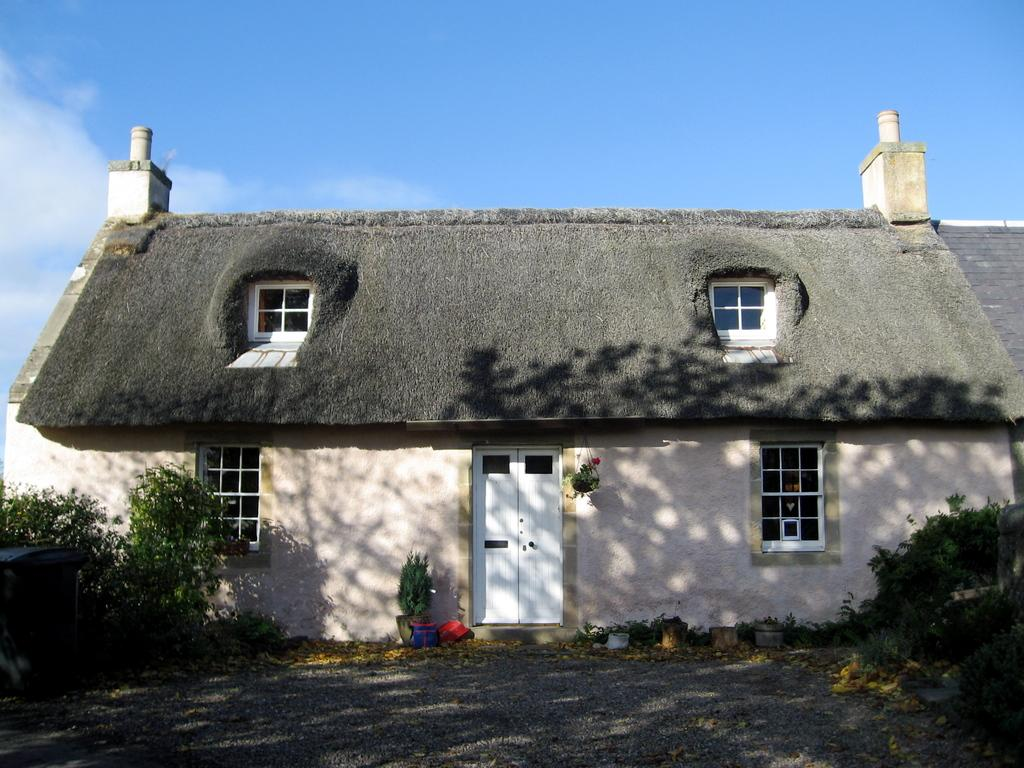What type of structure is visible in the image? There is a house in the image. What is located at the bottom of the image? There is a ground at the bottom of the image. What type of vegetation can be seen in the image? There are trees in the image. What is visible in the background of the image? The sky is visible in the background of the image. What can be observed in the sky? There are clouds in the sky. What type of paste is being used to hold the house together in the image? There is no mention of paste or any construction material in the image; it simply shows a house, trees, and the sky. 